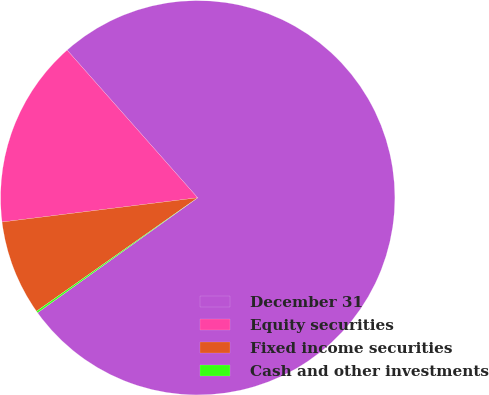<chart> <loc_0><loc_0><loc_500><loc_500><pie_chart><fcel>December 31<fcel>Equity securities<fcel>Fixed income securities<fcel>Cash and other investments<nl><fcel>76.61%<fcel>15.44%<fcel>7.8%<fcel>0.15%<nl></chart> 